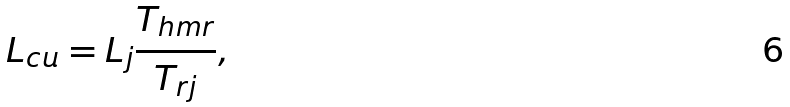Convert formula to latex. <formula><loc_0><loc_0><loc_500><loc_500>L _ { c u } = L _ { j } \frac { T _ { h m r } } { T _ { r j } } ,</formula> 